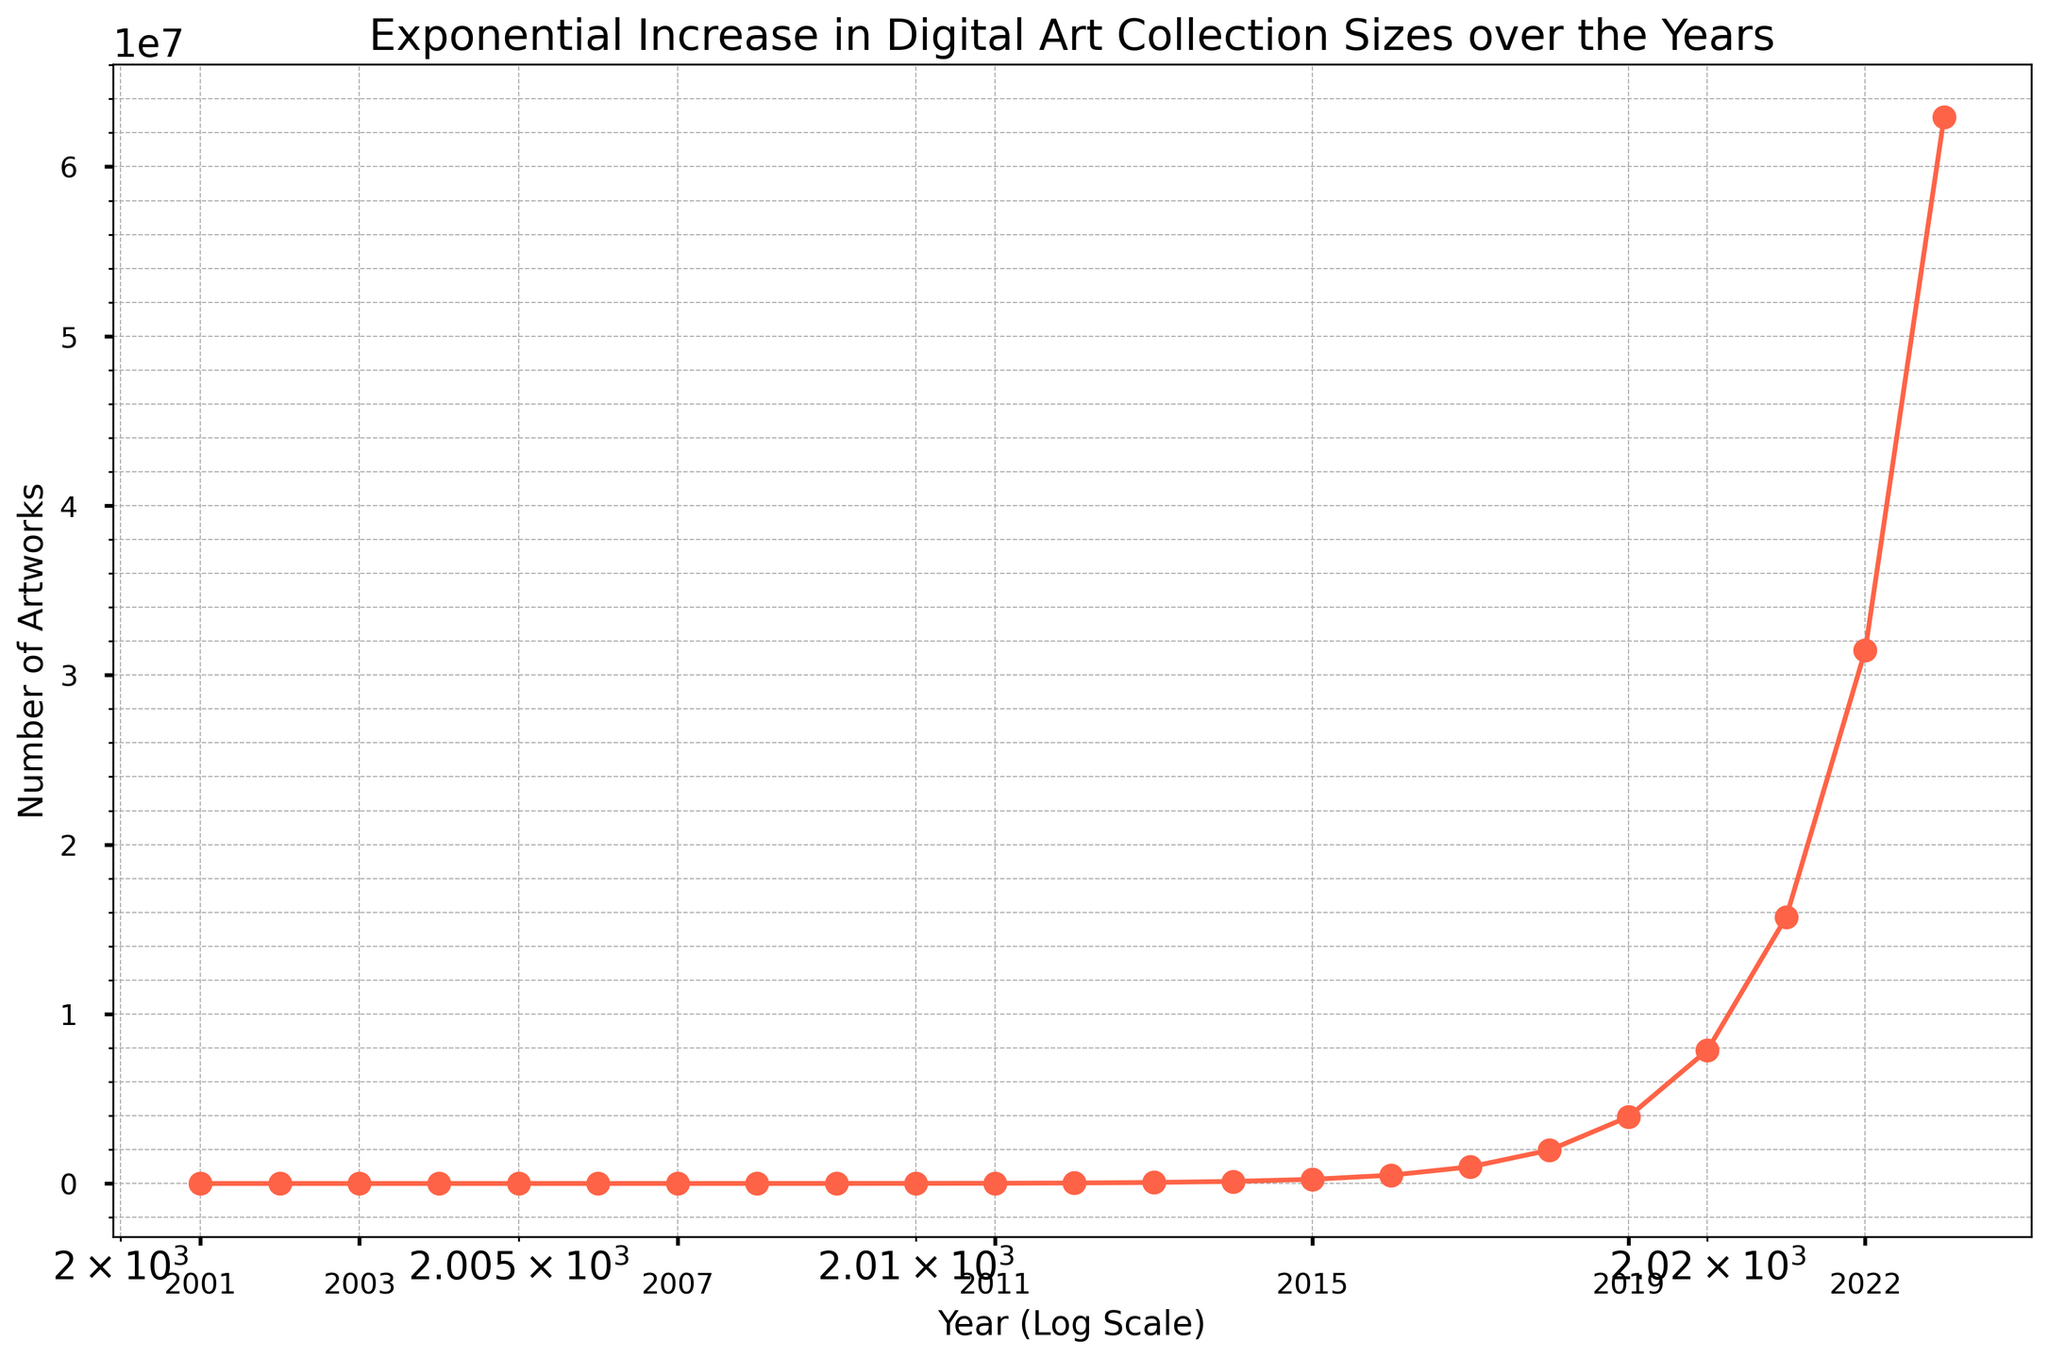What's the approximate number of artworks in 2010? Look at the data point on the figure corresponding to 2010 on the x-axis, and read the value on the y-axis
Answer: 7680 How much did the number of artworks increase from 2005 to 2010? Subtract the number of artworks in 2005 from the number in 2010 (7680 - 240)
Answer: 7440 Which year saw the greatest increase in the number of artworks? Compare the slopes between successive years; the steepest slope indicates the greatest increase
Answer: 2022 How does the number of artworks in 2023 compare to 2019? Compare the data points for 2023 and 2019. The number in 2023 is higher than in 2019
Answer: Greater in 2023 What's the visual trend observed in the digital art collection size over the years? Observe that the y-axis values increase exponentially as the x-axis moves from left to right, indicating exponential growth
Answer: Exponential increase How many times did the number of artworks approximately double between 2001 and 2005? Between 2001 (15 artworks) and 2005 (240 artworks): 15 to 30, 30 to 60, 60 to 120, 120 to 240. This is 4 doublings
Answer: 4 times In what year did the number of artworks first exceed 1,000,000? Identify the year where the y-axis value crosses 1,000,000; check successive points until 1,000,000 is surpassed in 2018
Answer: 2018 Which year had the smallest number of artworks? The smallest value on the y-axis is at the far left of the x-axis, corresponding to 2001
Answer: 2001 What does the color of the plot line indicate about the data trend? Visual cues such as color can emphasize the trend; here, red is often used to highlight significant or exponential increases
Answer: Exponential increase How does the grid and custom ticks aid in understanding the plot? The grid and custom ticks make it easier to read and interpret values, showing finer details and aiding in comparing years on a logarithmic scale
Answer: Improves readability and comparison 